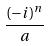<formula> <loc_0><loc_0><loc_500><loc_500>\frac { ( - i ) ^ { n } } { a }</formula> 